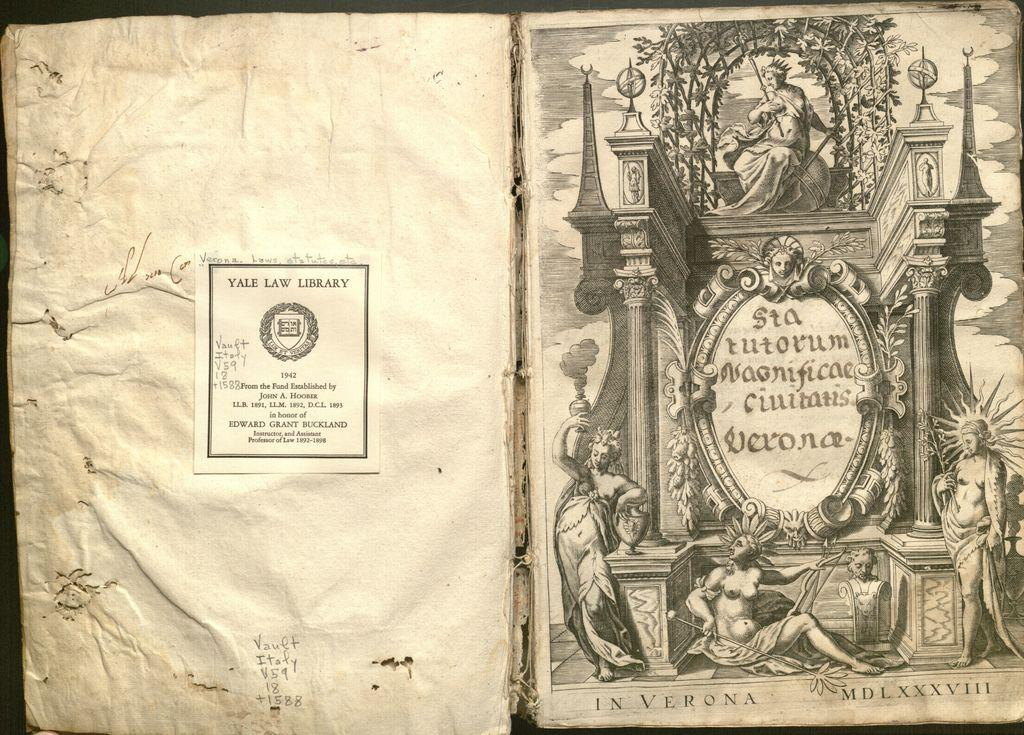<image>
Describe the image concisely. The paper has a label indicating it belongs to Yale Law Library. 